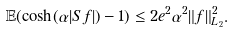Convert formula to latex. <formula><loc_0><loc_0><loc_500><loc_500>\mathbb { E } ( \cosh ( \alpha | S f | ) - 1 ) \leq 2 e ^ { 2 } \alpha ^ { 2 } \| f \| _ { L _ { 2 } } ^ { 2 } .</formula> 